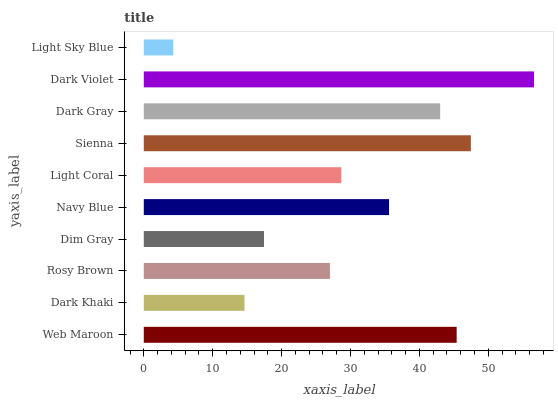Is Light Sky Blue the minimum?
Answer yes or no. Yes. Is Dark Violet the maximum?
Answer yes or no. Yes. Is Dark Khaki the minimum?
Answer yes or no. No. Is Dark Khaki the maximum?
Answer yes or no. No. Is Web Maroon greater than Dark Khaki?
Answer yes or no. Yes. Is Dark Khaki less than Web Maroon?
Answer yes or no. Yes. Is Dark Khaki greater than Web Maroon?
Answer yes or no. No. Is Web Maroon less than Dark Khaki?
Answer yes or no. No. Is Navy Blue the high median?
Answer yes or no. Yes. Is Light Coral the low median?
Answer yes or no. Yes. Is Web Maroon the high median?
Answer yes or no. No. Is Navy Blue the low median?
Answer yes or no. No. 